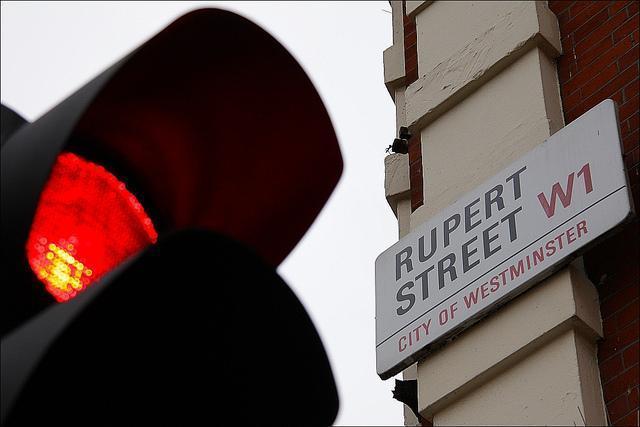How many people are wearing helmet?
Give a very brief answer. 0. 